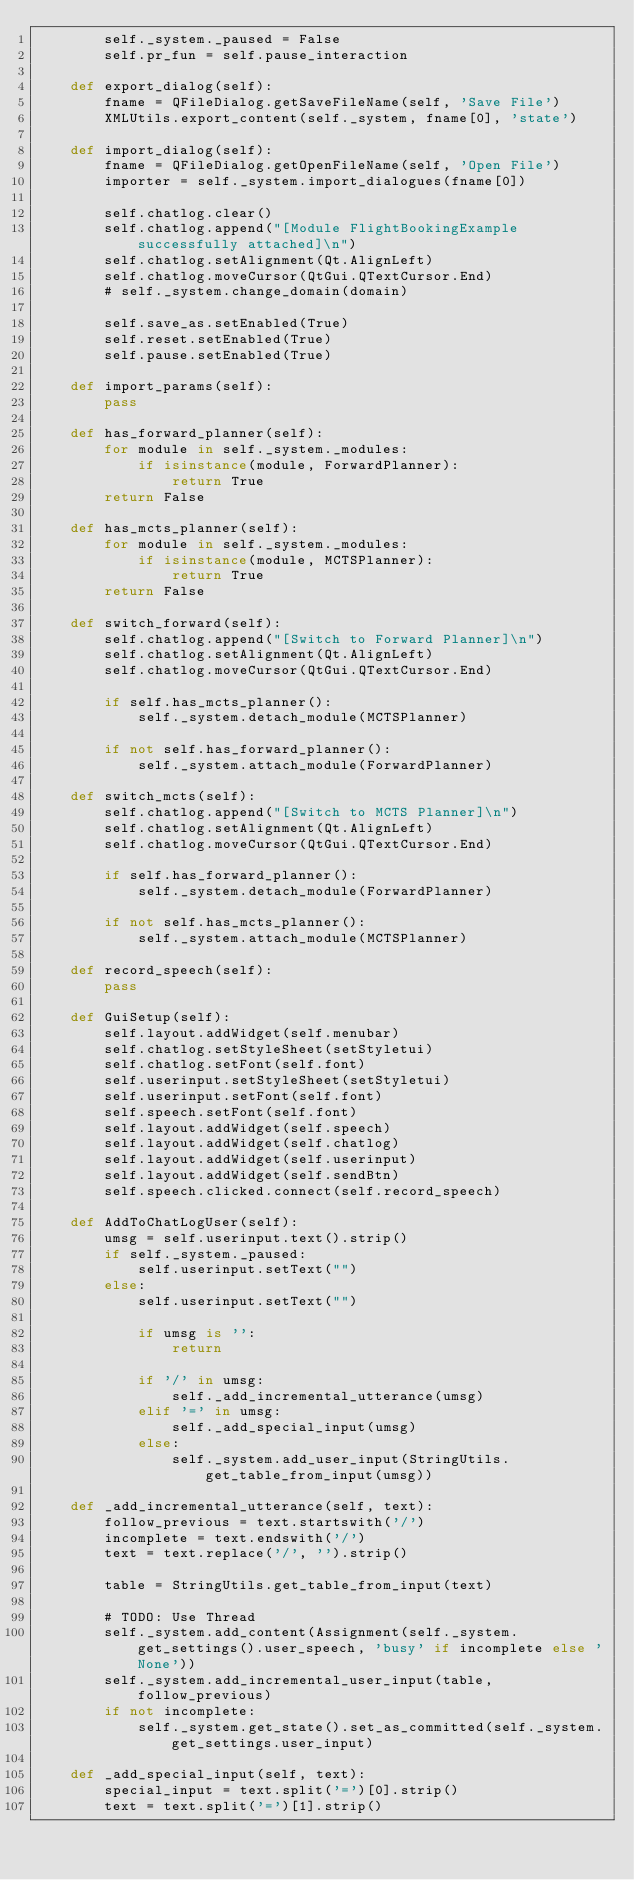<code> <loc_0><loc_0><loc_500><loc_500><_Python_>        self._system._paused = False
        self.pr_fun = self.pause_interaction

    def export_dialog(self):
        fname = QFileDialog.getSaveFileName(self, 'Save File')
        XMLUtils.export_content(self._system, fname[0], 'state')

    def import_dialog(self):
        fname = QFileDialog.getOpenFileName(self, 'Open File')
        importer = self._system.import_dialogues(fname[0])

        self.chatlog.clear()
        self.chatlog.append("[Module FlightBookingExample successfully attached]\n")
        self.chatlog.setAlignment(Qt.AlignLeft)
        self.chatlog.moveCursor(QtGui.QTextCursor.End)
        # self._system.change_domain(domain)

        self.save_as.setEnabled(True)
        self.reset.setEnabled(True)
        self.pause.setEnabled(True)

    def import_params(self):
        pass

    def has_forward_planner(self):
        for module in self._system._modules:
            if isinstance(module, ForwardPlanner):
                return True
        return False

    def has_mcts_planner(self):
        for module in self._system._modules:
            if isinstance(module, MCTSPlanner):
                return True
        return False

    def switch_forward(self):
        self.chatlog.append("[Switch to Forward Planner]\n")
        self.chatlog.setAlignment(Qt.AlignLeft)
        self.chatlog.moveCursor(QtGui.QTextCursor.End)

        if self.has_mcts_planner():
            self._system.detach_module(MCTSPlanner)

        if not self.has_forward_planner():
            self._system.attach_module(ForwardPlanner)

    def switch_mcts(self):
        self.chatlog.append("[Switch to MCTS Planner]\n")
        self.chatlog.setAlignment(Qt.AlignLeft)
        self.chatlog.moveCursor(QtGui.QTextCursor.End)

        if self.has_forward_planner():
            self._system.detach_module(ForwardPlanner)

        if not self.has_mcts_planner():
            self._system.attach_module(MCTSPlanner)

    def record_speech(self):
        pass

    def GuiSetup(self):
        self.layout.addWidget(self.menubar)
        self.chatlog.setStyleSheet(setStyletui)
        self.chatlog.setFont(self.font)
        self.userinput.setStyleSheet(setStyletui)
        self.userinput.setFont(self.font)
        self.speech.setFont(self.font)
        self.layout.addWidget(self.speech)
        self.layout.addWidget(self.chatlog)
        self.layout.addWidget(self.userinput)
        self.layout.addWidget(self.sendBtn)
        self.speech.clicked.connect(self.record_speech)

    def AddToChatLogUser(self):
        umsg = self.userinput.text().strip()
        if self._system._paused:
            self.userinput.setText("")
        else:
            self.userinput.setText("")

            if umsg is '':
                return

            if '/' in umsg:
                self._add_incremental_utterance(umsg)
            elif '=' in umsg:
                self._add_special_input(umsg)
            else:
                self._system.add_user_input(StringUtils.get_table_from_input(umsg))

    def _add_incremental_utterance(self, text):
        follow_previous = text.startswith('/')
        incomplete = text.endswith('/')
        text = text.replace('/', '').strip()

        table = StringUtils.get_table_from_input(text)

        # TODO: Use Thread
        self._system.add_content(Assignment(self._system.get_settings().user_speech, 'busy' if incomplete else 'None'))
        self._system.add_incremental_user_input(table, follow_previous)
        if not incomplete:
            self._system.get_state().set_as_committed(self._system.get_settings.user_input)

    def _add_special_input(self, text):
        special_input = text.split('=')[0].strip()
        text = text.split('=')[1].strip()
</code> 